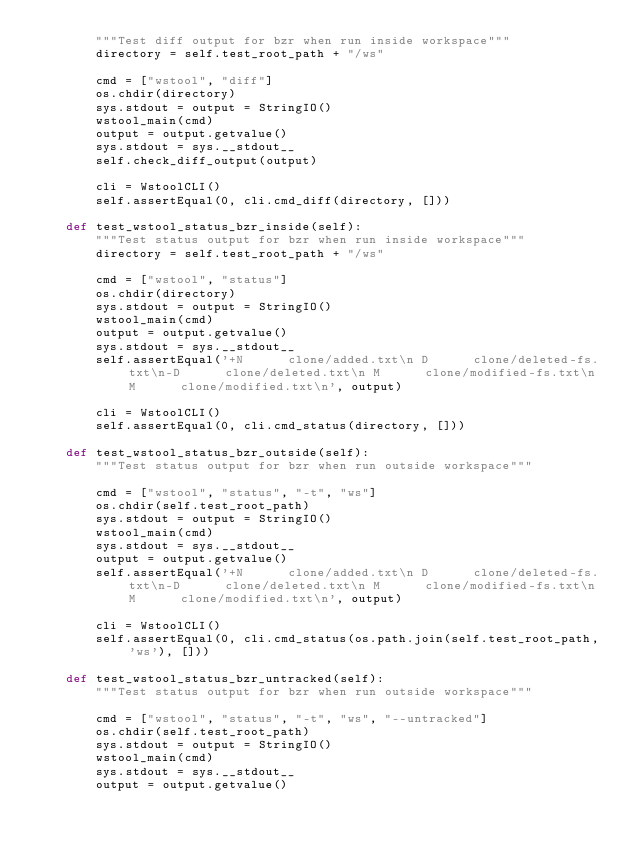<code> <loc_0><loc_0><loc_500><loc_500><_Python_>        """Test diff output for bzr when run inside workspace"""
        directory = self.test_root_path + "/ws"

        cmd = ["wstool", "diff"]
        os.chdir(directory)
        sys.stdout = output = StringIO()
        wstool_main(cmd)
        output = output.getvalue()
        sys.stdout = sys.__stdout__
        self.check_diff_output(output)

        cli = WstoolCLI()
        self.assertEqual(0, cli.cmd_diff(directory, []))

    def test_wstool_status_bzr_inside(self):
        """Test status output for bzr when run inside workspace"""
        directory = self.test_root_path + "/ws"

        cmd = ["wstool", "status"]
        os.chdir(directory)
        sys.stdout = output = StringIO()
        wstool_main(cmd)
        output = output.getvalue()
        sys.stdout = sys.__stdout__
        self.assertEqual('+N      clone/added.txt\n D      clone/deleted-fs.txt\n-D      clone/deleted.txt\n M      clone/modified-fs.txt\n M      clone/modified.txt\n', output)

        cli = WstoolCLI()
        self.assertEqual(0, cli.cmd_status(directory, []))

    def test_wstool_status_bzr_outside(self):
        """Test status output for bzr when run outside workspace"""

        cmd = ["wstool", "status", "-t", "ws"]
        os.chdir(self.test_root_path)
        sys.stdout = output = StringIO()
        wstool_main(cmd)
        sys.stdout = sys.__stdout__
        output = output.getvalue()
        self.assertEqual('+N      clone/added.txt\n D      clone/deleted-fs.txt\n-D      clone/deleted.txt\n M      clone/modified-fs.txt\n M      clone/modified.txt\n', output)

        cli = WstoolCLI()
        self.assertEqual(0, cli.cmd_status(os.path.join(self.test_root_path, 'ws'), []))

    def test_wstool_status_bzr_untracked(self):
        """Test status output for bzr when run outside workspace"""

        cmd = ["wstool", "status", "-t", "ws", "--untracked"]
        os.chdir(self.test_root_path)
        sys.stdout = output = StringIO()
        wstool_main(cmd)
        sys.stdout = sys.__stdout__
        output = output.getvalue()</code> 